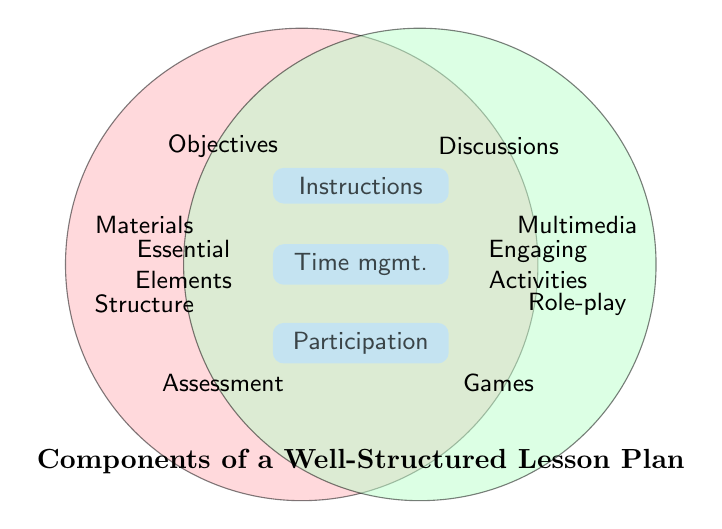What are the titles of the two main sets in the Venn Diagram? The labels for the two main sets are placed outside the circles. Set A is labeled "Essential Elements" and Set B is labeled "Engaging Activities".
Answer: "Essential Elements" and "Engaging Activities" Which components fall under both Essential Elements and Engaging Activities? The components in the intersection area of the Venn Diagram are colored differently and labeled distinctly. They are "Clear instructions", "Time management", and "Student participation".
Answer: "Clear instructions", "Time management", and "Student participation" How many components are unique to the Essential Elements set? By visually counting the elements solely in the left circle (not overlapping with the right circle), you can see there are four: "Objectives", "Assessment methods", "Materials needed", and "Lesson structure".
Answer: Four Which category has more unique elements, Essential Elements or Engaging Activities? By counting the non-overlapping items in each set, you compare the numbers. Essential Elements have four unique items, while Engaging Activities have five: "Group discussions", "Interactive games", "Multimedia presentations", "Role-playing exercises", and "Hands-on experiments".
Answer: Engaging Activities What component could indicate a structured approach to teaching? The component "Lesson structure" is under the Essential Elements set, indicating a structured approach in teaching.
Answer: "Lesson structure" Name one Engaging Activity that involves technology. "Multimedia presentations" are listed as an Engaging Activity that involves technology.
Answer: "Multimedia presentations" Could Group discussions be considered an Essential Element? By checking the location of "Group discussions", you see it only falls under Engaging Activities and not under Essential Elements or the intersection.
Answer: No List one key component from the intersection that promotes adaptability in lesson planning. "Adaptability" is within the intersection and it is closely linked to "Time management" which is crucial for being adaptive in lesson planning.
Answer: "Time management" Which unique component in Engaging Activities promotes interactive participation among students? "Interactive games" within the Engaging Activities set encourages interactive participation among students.
Answer: "Interactive games" Why might Reflection opportunities not be purely an Essential Element? Since "Reflection opportunities" is part of the union (as it is not listed), its absence in the Essential Elements set implies it's valued within Engaging Activities or combined components.
Answer: They are valued in interactive or engaging contexts 